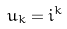<formula> <loc_0><loc_0><loc_500><loc_500>u _ { k } = i ^ { k }</formula> 